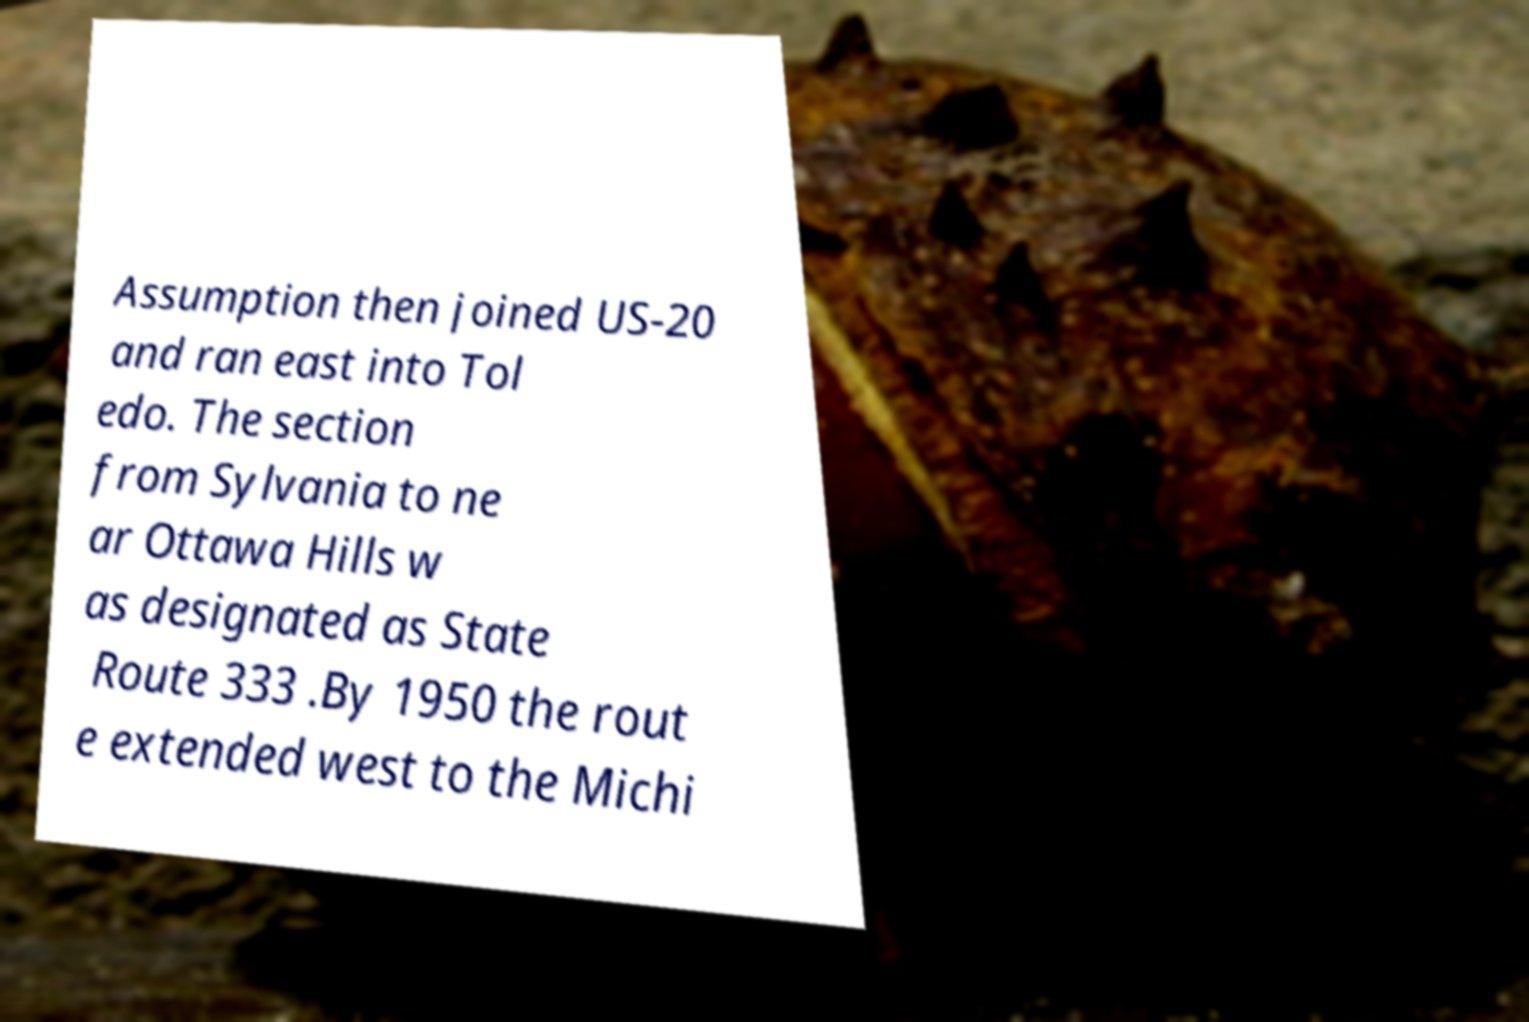I need the written content from this picture converted into text. Can you do that? Assumption then joined US-20 and ran east into Tol edo. The section from Sylvania to ne ar Ottawa Hills w as designated as State Route 333 .By 1950 the rout e extended west to the Michi 